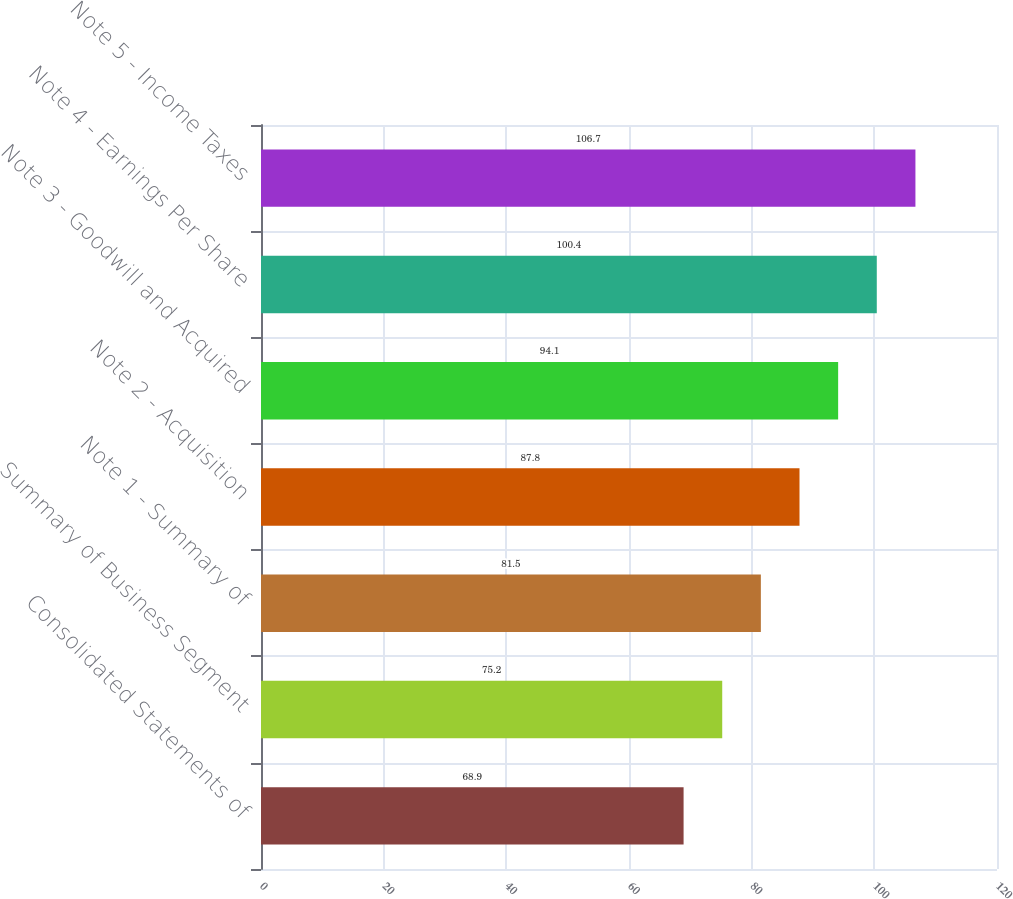Convert chart to OTSL. <chart><loc_0><loc_0><loc_500><loc_500><bar_chart><fcel>Consolidated Statements of<fcel>Summary of Business Segment<fcel>Note 1 - Summary of<fcel>Note 2 - Acquisition<fcel>Note 3 - Goodwill and Acquired<fcel>Note 4 - Earnings Per Share<fcel>Note 5 - Income Taxes<nl><fcel>68.9<fcel>75.2<fcel>81.5<fcel>87.8<fcel>94.1<fcel>100.4<fcel>106.7<nl></chart> 